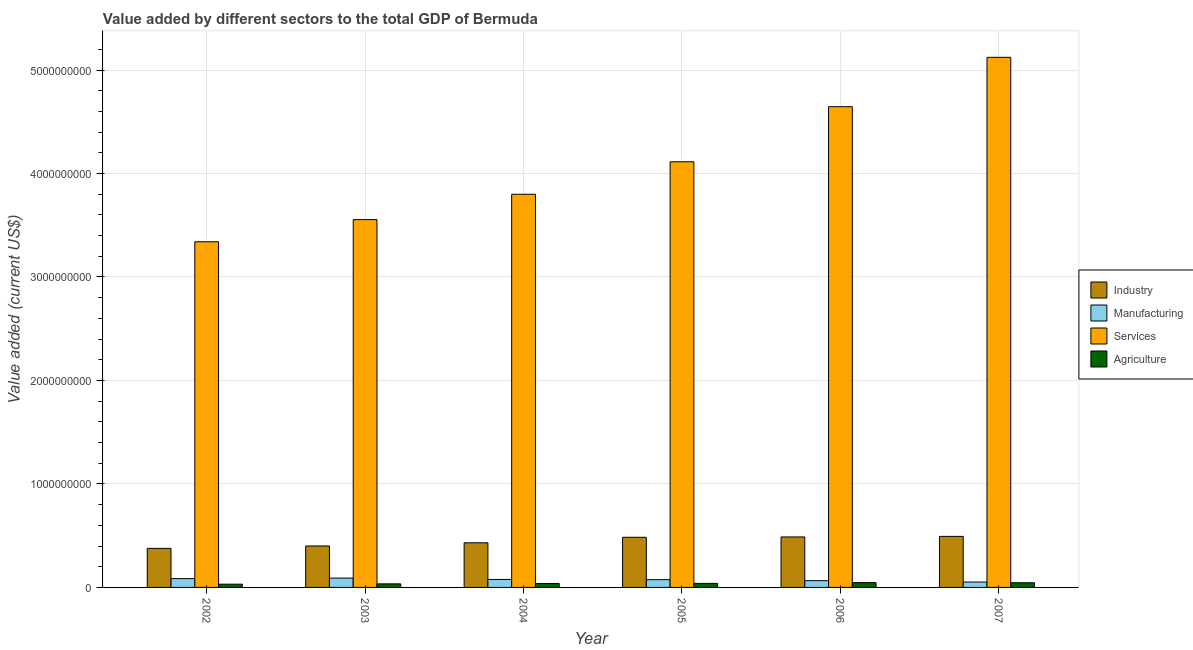How many different coloured bars are there?
Make the answer very short. 4. Are the number of bars per tick equal to the number of legend labels?
Give a very brief answer. Yes. How many bars are there on the 3rd tick from the left?
Make the answer very short. 4. How many bars are there on the 4th tick from the right?
Your answer should be compact. 4. What is the value added by agricultural sector in 2004?
Your response must be concise. 3.79e+07. Across all years, what is the maximum value added by industrial sector?
Your answer should be very brief. 4.93e+08. Across all years, what is the minimum value added by manufacturing sector?
Your answer should be compact. 5.21e+07. What is the total value added by services sector in the graph?
Provide a succinct answer. 2.46e+1. What is the difference between the value added by industrial sector in 2002 and that in 2005?
Your response must be concise. -1.07e+08. What is the difference between the value added by agricultural sector in 2004 and the value added by manufacturing sector in 2003?
Provide a succinct answer. 3.45e+06. What is the average value added by services sector per year?
Your answer should be compact. 4.10e+09. In how many years, is the value added by industrial sector greater than 3800000000 US$?
Offer a terse response. 0. What is the ratio of the value added by manufacturing sector in 2004 to that in 2006?
Provide a succinct answer. 1.18. Is the difference between the value added by industrial sector in 2004 and 2006 greater than the difference between the value added by manufacturing sector in 2004 and 2006?
Make the answer very short. No. What is the difference between the highest and the second highest value added by industrial sector?
Your answer should be compact. 5.36e+06. What is the difference between the highest and the lowest value added by industrial sector?
Offer a terse response. 1.16e+08. In how many years, is the value added by industrial sector greater than the average value added by industrial sector taken over all years?
Give a very brief answer. 3. Is the sum of the value added by industrial sector in 2004 and 2007 greater than the maximum value added by agricultural sector across all years?
Provide a short and direct response. Yes. What does the 1st bar from the left in 2004 represents?
Offer a terse response. Industry. What does the 2nd bar from the right in 2007 represents?
Your response must be concise. Services. Is it the case that in every year, the sum of the value added by industrial sector and value added by manufacturing sector is greater than the value added by services sector?
Ensure brevity in your answer.  No. Are all the bars in the graph horizontal?
Provide a succinct answer. No. Does the graph contain any zero values?
Ensure brevity in your answer.  No. How are the legend labels stacked?
Offer a terse response. Vertical. What is the title of the graph?
Make the answer very short. Value added by different sectors to the total GDP of Bermuda. Does "Other greenhouse gases" appear as one of the legend labels in the graph?
Offer a terse response. No. What is the label or title of the X-axis?
Your answer should be very brief. Year. What is the label or title of the Y-axis?
Your answer should be very brief. Value added (current US$). What is the Value added (current US$) of Industry in 2002?
Your answer should be compact. 3.77e+08. What is the Value added (current US$) in Manufacturing in 2002?
Your answer should be very brief. 8.50e+07. What is the Value added (current US$) of Services in 2002?
Provide a short and direct response. 3.34e+09. What is the Value added (current US$) of Agriculture in 2002?
Your response must be concise. 3.13e+07. What is the Value added (current US$) in Industry in 2003?
Offer a very short reply. 4.01e+08. What is the Value added (current US$) in Manufacturing in 2003?
Provide a short and direct response. 9.00e+07. What is the Value added (current US$) of Services in 2003?
Offer a terse response. 3.55e+09. What is the Value added (current US$) in Agriculture in 2003?
Make the answer very short. 3.44e+07. What is the Value added (current US$) of Industry in 2004?
Make the answer very short. 4.31e+08. What is the Value added (current US$) of Manufacturing in 2004?
Offer a terse response. 7.69e+07. What is the Value added (current US$) of Services in 2004?
Keep it short and to the point. 3.80e+09. What is the Value added (current US$) of Agriculture in 2004?
Your answer should be very brief. 3.79e+07. What is the Value added (current US$) in Industry in 2005?
Give a very brief answer. 4.84e+08. What is the Value added (current US$) of Manufacturing in 2005?
Ensure brevity in your answer.  7.48e+07. What is the Value added (current US$) in Services in 2005?
Provide a short and direct response. 4.11e+09. What is the Value added (current US$) in Agriculture in 2005?
Your answer should be very brief. 3.90e+07. What is the Value added (current US$) of Industry in 2006?
Your answer should be compact. 4.88e+08. What is the Value added (current US$) of Manufacturing in 2006?
Provide a succinct answer. 6.52e+07. What is the Value added (current US$) in Services in 2006?
Your answer should be compact. 4.65e+09. What is the Value added (current US$) in Agriculture in 2006?
Your answer should be very brief. 4.64e+07. What is the Value added (current US$) of Industry in 2007?
Provide a succinct answer. 4.93e+08. What is the Value added (current US$) in Manufacturing in 2007?
Your answer should be very brief. 5.21e+07. What is the Value added (current US$) in Services in 2007?
Your answer should be compact. 5.12e+09. What is the Value added (current US$) of Agriculture in 2007?
Give a very brief answer. 4.52e+07. Across all years, what is the maximum Value added (current US$) of Industry?
Make the answer very short. 4.93e+08. Across all years, what is the maximum Value added (current US$) in Manufacturing?
Your answer should be compact. 9.00e+07. Across all years, what is the maximum Value added (current US$) of Services?
Offer a terse response. 5.12e+09. Across all years, what is the maximum Value added (current US$) in Agriculture?
Provide a succinct answer. 4.64e+07. Across all years, what is the minimum Value added (current US$) of Industry?
Your answer should be very brief. 3.77e+08. Across all years, what is the minimum Value added (current US$) in Manufacturing?
Keep it short and to the point. 5.21e+07. Across all years, what is the minimum Value added (current US$) of Services?
Ensure brevity in your answer.  3.34e+09. Across all years, what is the minimum Value added (current US$) of Agriculture?
Your answer should be compact. 3.13e+07. What is the total Value added (current US$) of Industry in the graph?
Provide a short and direct response. 2.67e+09. What is the total Value added (current US$) in Manufacturing in the graph?
Offer a terse response. 4.44e+08. What is the total Value added (current US$) in Services in the graph?
Offer a terse response. 2.46e+1. What is the total Value added (current US$) of Agriculture in the graph?
Keep it short and to the point. 2.34e+08. What is the difference between the Value added (current US$) in Industry in 2002 and that in 2003?
Make the answer very short. -2.32e+07. What is the difference between the Value added (current US$) in Manufacturing in 2002 and that in 2003?
Provide a succinct answer. -5.06e+06. What is the difference between the Value added (current US$) of Services in 2002 and that in 2003?
Provide a short and direct response. -2.14e+08. What is the difference between the Value added (current US$) of Agriculture in 2002 and that in 2003?
Make the answer very short. -3.09e+06. What is the difference between the Value added (current US$) of Industry in 2002 and that in 2004?
Your response must be concise. -5.40e+07. What is the difference between the Value added (current US$) of Manufacturing in 2002 and that in 2004?
Offer a very short reply. 8.06e+06. What is the difference between the Value added (current US$) of Services in 2002 and that in 2004?
Give a very brief answer. -4.59e+08. What is the difference between the Value added (current US$) of Agriculture in 2002 and that in 2004?
Offer a terse response. -6.54e+06. What is the difference between the Value added (current US$) of Industry in 2002 and that in 2005?
Offer a terse response. -1.07e+08. What is the difference between the Value added (current US$) of Manufacturing in 2002 and that in 2005?
Your response must be concise. 1.02e+07. What is the difference between the Value added (current US$) of Services in 2002 and that in 2005?
Give a very brief answer. -7.73e+08. What is the difference between the Value added (current US$) of Agriculture in 2002 and that in 2005?
Your answer should be compact. -7.71e+06. What is the difference between the Value added (current US$) in Industry in 2002 and that in 2006?
Your response must be concise. -1.11e+08. What is the difference between the Value added (current US$) of Manufacturing in 2002 and that in 2006?
Your answer should be very brief. 1.98e+07. What is the difference between the Value added (current US$) in Services in 2002 and that in 2006?
Make the answer very short. -1.31e+09. What is the difference between the Value added (current US$) of Agriculture in 2002 and that in 2006?
Keep it short and to the point. -1.51e+07. What is the difference between the Value added (current US$) in Industry in 2002 and that in 2007?
Provide a short and direct response. -1.16e+08. What is the difference between the Value added (current US$) of Manufacturing in 2002 and that in 2007?
Provide a succinct answer. 3.29e+07. What is the difference between the Value added (current US$) in Services in 2002 and that in 2007?
Offer a terse response. -1.78e+09. What is the difference between the Value added (current US$) of Agriculture in 2002 and that in 2007?
Provide a short and direct response. -1.39e+07. What is the difference between the Value added (current US$) of Industry in 2003 and that in 2004?
Your answer should be compact. -3.08e+07. What is the difference between the Value added (current US$) in Manufacturing in 2003 and that in 2004?
Offer a very short reply. 1.31e+07. What is the difference between the Value added (current US$) in Services in 2003 and that in 2004?
Offer a terse response. -2.45e+08. What is the difference between the Value added (current US$) of Agriculture in 2003 and that in 2004?
Make the answer very short. -3.45e+06. What is the difference between the Value added (current US$) in Industry in 2003 and that in 2005?
Your answer should be very brief. -8.39e+07. What is the difference between the Value added (current US$) of Manufacturing in 2003 and that in 2005?
Give a very brief answer. 1.52e+07. What is the difference between the Value added (current US$) in Services in 2003 and that in 2005?
Offer a very short reply. -5.59e+08. What is the difference between the Value added (current US$) in Agriculture in 2003 and that in 2005?
Your answer should be very brief. -4.62e+06. What is the difference between the Value added (current US$) of Industry in 2003 and that in 2006?
Your answer should be compact. -8.73e+07. What is the difference between the Value added (current US$) in Manufacturing in 2003 and that in 2006?
Your answer should be very brief. 2.48e+07. What is the difference between the Value added (current US$) in Services in 2003 and that in 2006?
Ensure brevity in your answer.  -1.09e+09. What is the difference between the Value added (current US$) of Agriculture in 2003 and that in 2006?
Ensure brevity in your answer.  -1.20e+07. What is the difference between the Value added (current US$) of Industry in 2003 and that in 2007?
Keep it short and to the point. -9.26e+07. What is the difference between the Value added (current US$) of Manufacturing in 2003 and that in 2007?
Offer a terse response. 3.79e+07. What is the difference between the Value added (current US$) of Services in 2003 and that in 2007?
Give a very brief answer. -1.57e+09. What is the difference between the Value added (current US$) in Agriculture in 2003 and that in 2007?
Ensure brevity in your answer.  -1.08e+07. What is the difference between the Value added (current US$) of Industry in 2004 and that in 2005?
Your answer should be very brief. -5.31e+07. What is the difference between the Value added (current US$) of Manufacturing in 2004 and that in 2005?
Offer a terse response. 2.12e+06. What is the difference between the Value added (current US$) in Services in 2004 and that in 2005?
Your response must be concise. -3.14e+08. What is the difference between the Value added (current US$) in Agriculture in 2004 and that in 2005?
Offer a very short reply. -1.17e+06. What is the difference between the Value added (current US$) of Industry in 2004 and that in 2006?
Keep it short and to the point. -5.65e+07. What is the difference between the Value added (current US$) in Manufacturing in 2004 and that in 2006?
Provide a succinct answer. 1.17e+07. What is the difference between the Value added (current US$) in Services in 2004 and that in 2006?
Offer a terse response. -8.46e+08. What is the difference between the Value added (current US$) in Agriculture in 2004 and that in 2006?
Your response must be concise. -8.53e+06. What is the difference between the Value added (current US$) of Industry in 2004 and that in 2007?
Your answer should be very brief. -6.19e+07. What is the difference between the Value added (current US$) in Manufacturing in 2004 and that in 2007?
Keep it short and to the point. 2.48e+07. What is the difference between the Value added (current US$) in Services in 2004 and that in 2007?
Provide a succinct answer. -1.32e+09. What is the difference between the Value added (current US$) in Agriculture in 2004 and that in 2007?
Offer a terse response. -7.39e+06. What is the difference between the Value added (current US$) of Industry in 2005 and that in 2006?
Make the answer very short. -3.42e+06. What is the difference between the Value added (current US$) of Manufacturing in 2005 and that in 2006?
Provide a short and direct response. 9.58e+06. What is the difference between the Value added (current US$) of Services in 2005 and that in 2006?
Give a very brief answer. -5.32e+08. What is the difference between the Value added (current US$) of Agriculture in 2005 and that in 2006?
Your answer should be very brief. -7.36e+06. What is the difference between the Value added (current US$) of Industry in 2005 and that in 2007?
Make the answer very short. -8.78e+06. What is the difference between the Value added (current US$) in Manufacturing in 2005 and that in 2007?
Make the answer very short. 2.27e+07. What is the difference between the Value added (current US$) in Services in 2005 and that in 2007?
Your answer should be compact. -1.01e+09. What is the difference between the Value added (current US$) in Agriculture in 2005 and that in 2007?
Keep it short and to the point. -6.22e+06. What is the difference between the Value added (current US$) in Industry in 2006 and that in 2007?
Make the answer very short. -5.36e+06. What is the difference between the Value added (current US$) in Manufacturing in 2006 and that in 2007?
Your response must be concise. 1.31e+07. What is the difference between the Value added (current US$) in Services in 2006 and that in 2007?
Offer a terse response. -4.77e+08. What is the difference between the Value added (current US$) of Agriculture in 2006 and that in 2007?
Provide a short and direct response. 1.14e+06. What is the difference between the Value added (current US$) of Industry in 2002 and the Value added (current US$) of Manufacturing in 2003?
Your answer should be compact. 2.87e+08. What is the difference between the Value added (current US$) of Industry in 2002 and the Value added (current US$) of Services in 2003?
Give a very brief answer. -3.18e+09. What is the difference between the Value added (current US$) of Industry in 2002 and the Value added (current US$) of Agriculture in 2003?
Keep it short and to the point. 3.43e+08. What is the difference between the Value added (current US$) in Manufacturing in 2002 and the Value added (current US$) in Services in 2003?
Keep it short and to the point. -3.47e+09. What is the difference between the Value added (current US$) in Manufacturing in 2002 and the Value added (current US$) in Agriculture in 2003?
Give a very brief answer. 5.06e+07. What is the difference between the Value added (current US$) in Services in 2002 and the Value added (current US$) in Agriculture in 2003?
Give a very brief answer. 3.31e+09. What is the difference between the Value added (current US$) in Industry in 2002 and the Value added (current US$) in Manufacturing in 2004?
Offer a very short reply. 3.00e+08. What is the difference between the Value added (current US$) of Industry in 2002 and the Value added (current US$) of Services in 2004?
Give a very brief answer. -3.42e+09. What is the difference between the Value added (current US$) of Industry in 2002 and the Value added (current US$) of Agriculture in 2004?
Make the answer very short. 3.39e+08. What is the difference between the Value added (current US$) of Manufacturing in 2002 and the Value added (current US$) of Services in 2004?
Offer a very short reply. -3.71e+09. What is the difference between the Value added (current US$) in Manufacturing in 2002 and the Value added (current US$) in Agriculture in 2004?
Offer a terse response. 4.71e+07. What is the difference between the Value added (current US$) in Services in 2002 and the Value added (current US$) in Agriculture in 2004?
Offer a very short reply. 3.30e+09. What is the difference between the Value added (current US$) in Industry in 2002 and the Value added (current US$) in Manufacturing in 2005?
Ensure brevity in your answer.  3.03e+08. What is the difference between the Value added (current US$) of Industry in 2002 and the Value added (current US$) of Services in 2005?
Your answer should be very brief. -3.74e+09. What is the difference between the Value added (current US$) of Industry in 2002 and the Value added (current US$) of Agriculture in 2005?
Offer a very short reply. 3.38e+08. What is the difference between the Value added (current US$) of Manufacturing in 2002 and the Value added (current US$) of Services in 2005?
Keep it short and to the point. -4.03e+09. What is the difference between the Value added (current US$) of Manufacturing in 2002 and the Value added (current US$) of Agriculture in 2005?
Your answer should be compact. 4.60e+07. What is the difference between the Value added (current US$) in Services in 2002 and the Value added (current US$) in Agriculture in 2005?
Offer a very short reply. 3.30e+09. What is the difference between the Value added (current US$) of Industry in 2002 and the Value added (current US$) of Manufacturing in 2006?
Ensure brevity in your answer.  3.12e+08. What is the difference between the Value added (current US$) in Industry in 2002 and the Value added (current US$) in Services in 2006?
Your answer should be compact. -4.27e+09. What is the difference between the Value added (current US$) in Industry in 2002 and the Value added (current US$) in Agriculture in 2006?
Your answer should be compact. 3.31e+08. What is the difference between the Value added (current US$) in Manufacturing in 2002 and the Value added (current US$) in Services in 2006?
Give a very brief answer. -4.56e+09. What is the difference between the Value added (current US$) in Manufacturing in 2002 and the Value added (current US$) in Agriculture in 2006?
Keep it short and to the point. 3.86e+07. What is the difference between the Value added (current US$) in Services in 2002 and the Value added (current US$) in Agriculture in 2006?
Give a very brief answer. 3.29e+09. What is the difference between the Value added (current US$) in Industry in 2002 and the Value added (current US$) in Manufacturing in 2007?
Make the answer very short. 3.25e+08. What is the difference between the Value added (current US$) of Industry in 2002 and the Value added (current US$) of Services in 2007?
Offer a terse response. -4.75e+09. What is the difference between the Value added (current US$) of Industry in 2002 and the Value added (current US$) of Agriculture in 2007?
Give a very brief answer. 3.32e+08. What is the difference between the Value added (current US$) in Manufacturing in 2002 and the Value added (current US$) in Services in 2007?
Your answer should be compact. -5.04e+09. What is the difference between the Value added (current US$) in Manufacturing in 2002 and the Value added (current US$) in Agriculture in 2007?
Give a very brief answer. 3.97e+07. What is the difference between the Value added (current US$) in Services in 2002 and the Value added (current US$) in Agriculture in 2007?
Make the answer very short. 3.30e+09. What is the difference between the Value added (current US$) of Industry in 2003 and the Value added (current US$) of Manufacturing in 2004?
Your response must be concise. 3.24e+08. What is the difference between the Value added (current US$) of Industry in 2003 and the Value added (current US$) of Services in 2004?
Your answer should be very brief. -3.40e+09. What is the difference between the Value added (current US$) in Industry in 2003 and the Value added (current US$) in Agriculture in 2004?
Offer a very short reply. 3.63e+08. What is the difference between the Value added (current US$) of Manufacturing in 2003 and the Value added (current US$) of Services in 2004?
Ensure brevity in your answer.  -3.71e+09. What is the difference between the Value added (current US$) of Manufacturing in 2003 and the Value added (current US$) of Agriculture in 2004?
Offer a very short reply. 5.22e+07. What is the difference between the Value added (current US$) of Services in 2003 and the Value added (current US$) of Agriculture in 2004?
Ensure brevity in your answer.  3.52e+09. What is the difference between the Value added (current US$) in Industry in 2003 and the Value added (current US$) in Manufacturing in 2005?
Provide a succinct answer. 3.26e+08. What is the difference between the Value added (current US$) of Industry in 2003 and the Value added (current US$) of Services in 2005?
Make the answer very short. -3.71e+09. What is the difference between the Value added (current US$) in Industry in 2003 and the Value added (current US$) in Agriculture in 2005?
Provide a succinct answer. 3.62e+08. What is the difference between the Value added (current US$) in Manufacturing in 2003 and the Value added (current US$) in Services in 2005?
Keep it short and to the point. -4.02e+09. What is the difference between the Value added (current US$) in Manufacturing in 2003 and the Value added (current US$) in Agriculture in 2005?
Offer a terse response. 5.10e+07. What is the difference between the Value added (current US$) of Services in 2003 and the Value added (current US$) of Agriculture in 2005?
Ensure brevity in your answer.  3.52e+09. What is the difference between the Value added (current US$) in Industry in 2003 and the Value added (current US$) in Manufacturing in 2006?
Offer a terse response. 3.35e+08. What is the difference between the Value added (current US$) in Industry in 2003 and the Value added (current US$) in Services in 2006?
Provide a short and direct response. -4.25e+09. What is the difference between the Value added (current US$) in Industry in 2003 and the Value added (current US$) in Agriculture in 2006?
Your response must be concise. 3.54e+08. What is the difference between the Value added (current US$) in Manufacturing in 2003 and the Value added (current US$) in Services in 2006?
Keep it short and to the point. -4.56e+09. What is the difference between the Value added (current US$) in Manufacturing in 2003 and the Value added (current US$) in Agriculture in 2006?
Your answer should be very brief. 4.37e+07. What is the difference between the Value added (current US$) of Services in 2003 and the Value added (current US$) of Agriculture in 2006?
Provide a short and direct response. 3.51e+09. What is the difference between the Value added (current US$) in Industry in 2003 and the Value added (current US$) in Manufacturing in 2007?
Ensure brevity in your answer.  3.48e+08. What is the difference between the Value added (current US$) in Industry in 2003 and the Value added (current US$) in Services in 2007?
Your response must be concise. -4.72e+09. What is the difference between the Value added (current US$) in Industry in 2003 and the Value added (current US$) in Agriculture in 2007?
Make the answer very short. 3.55e+08. What is the difference between the Value added (current US$) of Manufacturing in 2003 and the Value added (current US$) of Services in 2007?
Your answer should be very brief. -5.03e+09. What is the difference between the Value added (current US$) in Manufacturing in 2003 and the Value added (current US$) in Agriculture in 2007?
Provide a succinct answer. 4.48e+07. What is the difference between the Value added (current US$) of Services in 2003 and the Value added (current US$) of Agriculture in 2007?
Provide a short and direct response. 3.51e+09. What is the difference between the Value added (current US$) of Industry in 2004 and the Value added (current US$) of Manufacturing in 2005?
Provide a succinct answer. 3.57e+08. What is the difference between the Value added (current US$) in Industry in 2004 and the Value added (current US$) in Services in 2005?
Provide a succinct answer. -3.68e+09. What is the difference between the Value added (current US$) of Industry in 2004 and the Value added (current US$) of Agriculture in 2005?
Ensure brevity in your answer.  3.92e+08. What is the difference between the Value added (current US$) in Manufacturing in 2004 and the Value added (current US$) in Services in 2005?
Provide a short and direct response. -4.04e+09. What is the difference between the Value added (current US$) of Manufacturing in 2004 and the Value added (current US$) of Agriculture in 2005?
Your answer should be compact. 3.79e+07. What is the difference between the Value added (current US$) in Services in 2004 and the Value added (current US$) in Agriculture in 2005?
Keep it short and to the point. 3.76e+09. What is the difference between the Value added (current US$) of Industry in 2004 and the Value added (current US$) of Manufacturing in 2006?
Offer a very short reply. 3.66e+08. What is the difference between the Value added (current US$) in Industry in 2004 and the Value added (current US$) in Services in 2006?
Make the answer very short. -4.21e+09. What is the difference between the Value added (current US$) of Industry in 2004 and the Value added (current US$) of Agriculture in 2006?
Your answer should be very brief. 3.85e+08. What is the difference between the Value added (current US$) in Manufacturing in 2004 and the Value added (current US$) in Services in 2006?
Ensure brevity in your answer.  -4.57e+09. What is the difference between the Value added (current US$) of Manufacturing in 2004 and the Value added (current US$) of Agriculture in 2006?
Offer a very short reply. 3.05e+07. What is the difference between the Value added (current US$) in Services in 2004 and the Value added (current US$) in Agriculture in 2006?
Ensure brevity in your answer.  3.75e+09. What is the difference between the Value added (current US$) in Industry in 2004 and the Value added (current US$) in Manufacturing in 2007?
Your response must be concise. 3.79e+08. What is the difference between the Value added (current US$) in Industry in 2004 and the Value added (current US$) in Services in 2007?
Give a very brief answer. -4.69e+09. What is the difference between the Value added (current US$) in Industry in 2004 and the Value added (current US$) in Agriculture in 2007?
Ensure brevity in your answer.  3.86e+08. What is the difference between the Value added (current US$) in Manufacturing in 2004 and the Value added (current US$) in Services in 2007?
Offer a terse response. -5.05e+09. What is the difference between the Value added (current US$) in Manufacturing in 2004 and the Value added (current US$) in Agriculture in 2007?
Keep it short and to the point. 3.17e+07. What is the difference between the Value added (current US$) in Services in 2004 and the Value added (current US$) in Agriculture in 2007?
Your response must be concise. 3.75e+09. What is the difference between the Value added (current US$) of Industry in 2005 and the Value added (current US$) of Manufacturing in 2006?
Provide a succinct answer. 4.19e+08. What is the difference between the Value added (current US$) in Industry in 2005 and the Value added (current US$) in Services in 2006?
Your answer should be compact. -4.16e+09. What is the difference between the Value added (current US$) in Industry in 2005 and the Value added (current US$) in Agriculture in 2006?
Your answer should be compact. 4.38e+08. What is the difference between the Value added (current US$) of Manufacturing in 2005 and the Value added (current US$) of Services in 2006?
Your answer should be compact. -4.57e+09. What is the difference between the Value added (current US$) of Manufacturing in 2005 and the Value added (current US$) of Agriculture in 2006?
Provide a succinct answer. 2.84e+07. What is the difference between the Value added (current US$) in Services in 2005 and the Value added (current US$) in Agriculture in 2006?
Offer a terse response. 4.07e+09. What is the difference between the Value added (current US$) of Industry in 2005 and the Value added (current US$) of Manufacturing in 2007?
Provide a succinct answer. 4.32e+08. What is the difference between the Value added (current US$) of Industry in 2005 and the Value added (current US$) of Services in 2007?
Your answer should be compact. -4.64e+09. What is the difference between the Value added (current US$) in Industry in 2005 and the Value added (current US$) in Agriculture in 2007?
Make the answer very short. 4.39e+08. What is the difference between the Value added (current US$) in Manufacturing in 2005 and the Value added (current US$) in Services in 2007?
Your response must be concise. -5.05e+09. What is the difference between the Value added (current US$) in Manufacturing in 2005 and the Value added (current US$) in Agriculture in 2007?
Provide a short and direct response. 2.96e+07. What is the difference between the Value added (current US$) in Services in 2005 and the Value added (current US$) in Agriculture in 2007?
Your response must be concise. 4.07e+09. What is the difference between the Value added (current US$) of Industry in 2006 and the Value added (current US$) of Manufacturing in 2007?
Offer a very short reply. 4.36e+08. What is the difference between the Value added (current US$) in Industry in 2006 and the Value added (current US$) in Services in 2007?
Your answer should be compact. -4.63e+09. What is the difference between the Value added (current US$) of Industry in 2006 and the Value added (current US$) of Agriculture in 2007?
Your answer should be very brief. 4.43e+08. What is the difference between the Value added (current US$) in Manufacturing in 2006 and the Value added (current US$) in Services in 2007?
Provide a succinct answer. -5.06e+09. What is the difference between the Value added (current US$) of Manufacturing in 2006 and the Value added (current US$) of Agriculture in 2007?
Your answer should be compact. 2.00e+07. What is the difference between the Value added (current US$) of Services in 2006 and the Value added (current US$) of Agriculture in 2007?
Your answer should be compact. 4.60e+09. What is the average Value added (current US$) of Industry per year?
Make the answer very short. 4.46e+08. What is the average Value added (current US$) in Manufacturing per year?
Offer a terse response. 7.40e+07. What is the average Value added (current US$) of Services per year?
Offer a very short reply. 4.10e+09. What is the average Value added (current US$) in Agriculture per year?
Keep it short and to the point. 3.90e+07. In the year 2002, what is the difference between the Value added (current US$) in Industry and Value added (current US$) in Manufacturing?
Your answer should be very brief. 2.92e+08. In the year 2002, what is the difference between the Value added (current US$) in Industry and Value added (current US$) in Services?
Give a very brief answer. -2.96e+09. In the year 2002, what is the difference between the Value added (current US$) in Industry and Value added (current US$) in Agriculture?
Keep it short and to the point. 3.46e+08. In the year 2002, what is the difference between the Value added (current US$) of Manufacturing and Value added (current US$) of Services?
Offer a terse response. -3.26e+09. In the year 2002, what is the difference between the Value added (current US$) of Manufacturing and Value added (current US$) of Agriculture?
Provide a short and direct response. 5.37e+07. In the year 2002, what is the difference between the Value added (current US$) of Services and Value added (current US$) of Agriculture?
Your answer should be compact. 3.31e+09. In the year 2003, what is the difference between the Value added (current US$) in Industry and Value added (current US$) in Manufacturing?
Make the answer very short. 3.11e+08. In the year 2003, what is the difference between the Value added (current US$) of Industry and Value added (current US$) of Services?
Your answer should be compact. -3.15e+09. In the year 2003, what is the difference between the Value added (current US$) in Industry and Value added (current US$) in Agriculture?
Your answer should be compact. 3.66e+08. In the year 2003, what is the difference between the Value added (current US$) of Manufacturing and Value added (current US$) of Services?
Your response must be concise. -3.46e+09. In the year 2003, what is the difference between the Value added (current US$) in Manufacturing and Value added (current US$) in Agriculture?
Keep it short and to the point. 5.56e+07. In the year 2003, what is the difference between the Value added (current US$) of Services and Value added (current US$) of Agriculture?
Ensure brevity in your answer.  3.52e+09. In the year 2004, what is the difference between the Value added (current US$) in Industry and Value added (current US$) in Manufacturing?
Ensure brevity in your answer.  3.54e+08. In the year 2004, what is the difference between the Value added (current US$) in Industry and Value added (current US$) in Services?
Your response must be concise. -3.37e+09. In the year 2004, what is the difference between the Value added (current US$) of Industry and Value added (current US$) of Agriculture?
Provide a succinct answer. 3.93e+08. In the year 2004, what is the difference between the Value added (current US$) in Manufacturing and Value added (current US$) in Services?
Ensure brevity in your answer.  -3.72e+09. In the year 2004, what is the difference between the Value added (current US$) of Manufacturing and Value added (current US$) of Agriculture?
Provide a short and direct response. 3.91e+07. In the year 2004, what is the difference between the Value added (current US$) of Services and Value added (current US$) of Agriculture?
Offer a terse response. 3.76e+09. In the year 2005, what is the difference between the Value added (current US$) of Industry and Value added (current US$) of Manufacturing?
Provide a succinct answer. 4.10e+08. In the year 2005, what is the difference between the Value added (current US$) in Industry and Value added (current US$) in Services?
Keep it short and to the point. -3.63e+09. In the year 2005, what is the difference between the Value added (current US$) in Industry and Value added (current US$) in Agriculture?
Provide a succinct answer. 4.45e+08. In the year 2005, what is the difference between the Value added (current US$) of Manufacturing and Value added (current US$) of Services?
Keep it short and to the point. -4.04e+09. In the year 2005, what is the difference between the Value added (current US$) of Manufacturing and Value added (current US$) of Agriculture?
Provide a succinct answer. 3.58e+07. In the year 2005, what is the difference between the Value added (current US$) in Services and Value added (current US$) in Agriculture?
Your answer should be compact. 4.07e+09. In the year 2006, what is the difference between the Value added (current US$) of Industry and Value added (current US$) of Manufacturing?
Ensure brevity in your answer.  4.23e+08. In the year 2006, what is the difference between the Value added (current US$) in Industry and Value added (current US$) in Services?
Keep it short and to the point. -4.16e+09. In the year 2006, what is the difference between the Value added (current US$) of Industry and Value added (current US$) of Agriculture?
Provide a succinct answer. 4.41e+08. In the year 2006, what is the difference between the Value added (current US$) of Manufacturing and Value added (current US$) of Services?
Give a very brief answer. -4.58e+09. In the year 2006, what is the difference between the Value added (current US$) of Manufacturing and Value added (current US$) of Agriculture?
Give a very brief answer. 1.88e+07. In the year 2006, what is the difference between the Value added (current US$) of Services and Value added (current US$) of Agriculture?
Offer a terse response. 4.60e+09. In the year 2007, what is the difference between the Value added (current US$) in Industry and Value added (current US$) in Manufacturing?
Ensure brevity in your answer.  4.41e+08. In the year 2007, what is the difference between the Value added (current US$) in Industry and Value added (current US$) in Services?
Offer a terse response. -4.63e+09. In the year 2007, what is the difference between the Value added (current US$) in Industry and Value added (current US$) in Agriculture?
Provide a short and direct response. 4.48e+08. In the year 2007, what is the difference between the Value added (current US$) in Manufacturing and Value added (current US$) in Services?
Your answer should be compact. -5.07e+09. In the year 2007, what is the difference between the Value added (current US$) in Manufacturing and Value added (current US$) in Agriculture?
Your answer should be compact. 6.85e+06. In the year 2007, what is the difference between the Value added (current US$) of Services and Value added (current US$) of Agriculture?
Your answer should be very brief. 5.08e+09. What is the ratio of the Value added (current US$) of Industry in 2002 to that in 2003?
Offer a very short reply. 0.94. What is the ratio of the Value added (current US$) in Manufacturing in 2002 to that in 2003?
Offer a very short reply. 0.94. What is the ratio of the Value added (current US$) in Services in 2002 to that in 2003?
Give a very brief answer. 0.94. What is the ratio of the Value added (current US$) of Agriculture in 2002 to that in 2003?
Your answer should be compact. 0.91. What is the ratio of the Value added (current US$) in Industry in 2002 to that in 2004?
Ensure brevity in your answer.  0.87. What is the ratio of the Value added (current US$) in Manufacturing in 2002 to that in 2004?
Make the answer very short. 1.1. What is the ratio of the Value added (current US$) in Services in 2002 to that in 2004?
Your answer should be very brief. 0.88. What is the ratio of the Value added (current US$) of Agriculture in 2002 to that in 2004?
Make the answer very short. 0.83. What is the ratio of the Value added (current US$) of Industry in 2002 to that in 2005?
Make the answer very short. 0.78. What is the ratio of the Value added (current US$) of Manufacturing in 2002 to that in 2005?
Provide a succinct answer. 1.14. What is the ratio of the Value added (current US$) in Services in 2002 to that in 2005?
Your answer should be very brief. 0.81. What is the ratio of the Value added (current US$) of Agriculture in 2002 to that in 2005?
Keep it short and to the point. 0.8. What is the ratio of the Value added (current US$) in Industry in 2002 to that in 2006?
Your response must be concise. 0.77. What is the ratio of the Value added (current US$) of Manufacturing in 2002 to that in 2006?
Your answer should be very brief. 1.3. What is the ratio of the Value added (current US$) of Services in 2002 to that in 2006?
Keep it short and to the point. 0.72. What is the ratio of the Value added (current US$) in Agriculture in 2002 to that in 2006?
Offer a terse response. 0.68. What is the ratio of the Value added (current US$) in Industry in 2002 to that in 2007?
Ensure brevity in your answer.  0.77. What is the ratio of the Value added (current US$) of Manufacturing in 2002 to that in 2007?
Offer a terse response. 1.63. What is the ratio of the Value added (current US$) of Services in 2002 to that in 2007?
Provide a succinct answer. 0.65. What is the ratio of the Value added (current US$) of Agriculture in 2002 to that in 2007?
Keep it short and to the point. 0.69. What is the ratio of the Value added (current US$) in Manufacturing in 2003 to that in 2004?
Make the answer very short. 1.17. What is the ratio of the Value added (current US$) in Services in 2003 to that in 2004?
Offer a very short reply. 0.94. What is the ratio of the Value added (current US$) in Agriculture in 2003 to that in 2004?
Your answer should be compact. 0.91. What is the ratio of the Value added (current US$) of Industry in 2003 to that in 2005?
Offer a terse response. 0.83. What is the ratio of the Value added (current US$) in Manufacturing in 2003 to that in 2005?
Your response must be concise. 1.2. What is the ratio of the Value added (current US$) of Services in 2003 to that in 2005?
Offer a terse response. 0.86. What is the ratio of the Value added (current US$) in Agriculture in 2003 to that in 2005?
Make the answer very short. 0.88. What is the ratio of the Value added (current US$) in Industry in 2003 to that in 2006?
Your answer should be very brief. 0.82. What is the ratio of the Value added (current US$) of Manufacturing in 2003 to that in 2006?
Your answer should be very brief. 1.38. What is the ratio of the Value added (current US$) in Services in 2003 to that in 2006?
Your answer should be very brief. 0.77. What is the ratio of the Value added (current US$) of Agriculture in 2003 to that in 2006?
Your answer should be compact. 0.74. What is the ratio of the Value added (current US$) in Industry in 2003 to that in 2007?
Provide a short and direct response. 0.81. What is the ratio of the Value added (current US$) in Manufacturing in 2003 to that in 2007?
Provide a succinct answer. 1.73. What is the ratio of the Value added (current US$) in Services in 2003 to that in 2007?
Give a very brief answer. 0.69. What is the ratio of the Value added (current US$) of Agriculture in 2003 to that in 2007?
Keep it short and to the point. 0.76. What is the ratio of the Value added (current US$) of Industry in 2004 to that in 2005?
Offer a terse response. 0.89. What is the ratio of the Value added (current US$) in Manufacturing in 2004 to that in 2005?
Keep it short and to the point. 1.03. What is the ratio of the Value added (current US$) in Services in 2004 to that in 2005?
Offer a terse response. 0.92. What is the ratio of the Value added (current US$) in Agriculture in 2004 to that in 2005?
Your answer should be very brief. 0.97. What is the ratio of the Value added (current US$) of Industry in 2004 to that in 2006?
Your answer should be compact. 0.88. What is the ratio of the Value added (current US$) of Manufacturing in 2004 to that in 2006?
Provide a succinct answer. 1.18. What is the ratio of the Value added (current US$) in Services in 2004 to that in 2006?
Make the answer very short. 0.82. What is the ratio of the Value added (current US$) in Agriculture in 2004 to that in 2006?
Your response must be concise. 0.82. What is the ratio of the Value added (current US$) in Industry in 2004 to that in 2007?
Ensure brevity in your answer.  0.87. What is the ratio of the Value added (current US$) in Manufacturing in 2004 to that in 2007?
Ensure brevity in your answer.  1.48. What is the ratio of the Value added (current US$) of Services in 2004 to that in 2007?
Your answer should be compact. 0.74. What is the ratio of the Value added (current US$) in Agriculture in 2004 to that in 2007?
Provide a short and direct response. 0.84. What is the ratio of the Value added (current US$) in Industry in 2005 to that in 2006?
Provide a short and direct response. 0.99. What is the ratio of the Value added (current US$) in Manufacturing in 2005 to that in 2006?
Offer a terse response. 1.15. What is the ratio of the Value added (current US$) of Services in 2005 to that in 2006?
Keep it short and to the point. 0.89. What is the ratio of the Value added (current US$) of Agriculture in 2005 to that in 2006?
Your answer should be very brief. 0.84. What is the ratio of the Value added (current US$) in Industry in 2005 to that in 2007?
Make the answer very short. 0.98. What is the ratio of the Value added (current US$) in Manufacturing in 2005 to that in 2007?
Give a very brief answer. 1.44. What is the ratio of the Value added (current US$) of Services in 2005 to that in 2007?
Offer a very short reply. 0.8. What is the ratio of the Value added (current US$) of Agriculture in 2005 to that in 2007?
Make the answer very short. 0.86. What is the ratio of the Value added (current US$) in Manufacturing in 2006 to that in 2007?
Make the answer very short. 1.25. What is the ratio of the Value added (current US$) in Services in 2006 to that in 2007?
Offer a terse response. 0.91. What is the ratio of the Value added (current US$) of Agriculture in 2006 to that in 2007?
Keep it short and to the point. 1.03. What is the difference between the highest and the second highest Value added (current US$) in Industry?
Your answer should be compact. 5.36e+06. What is the difference between the highest and the second highest Value added (current US$) in Manufacturing?
Keep it short and to the point. 5.06e+06. What is the difference between the highest and the second highest Value added (current US$) in Services?
Offer a very short reply. 4.77e+08. What is the difference between the highest and the second highest Value added (current US$) in Agriculture?
Offer a terse response. 1.14e+06. What is the difference between the highest and the lowest Value added (current US$) of Industry?
Your answer should be compact. 1.16e+08. What is the difference between the highest and the lowest Value added (current US$) of Manufacturing?
Your answer should be compact. 3.79e+07. What is the difference between the highest and the lowest Value added (current US$) in Services?
Your answer should be very brief. 1.78e+09. What is the difference between the highest and the lowest Value added (current US$) of Agriculture?
Your response must be concise. 1.51e+07. 